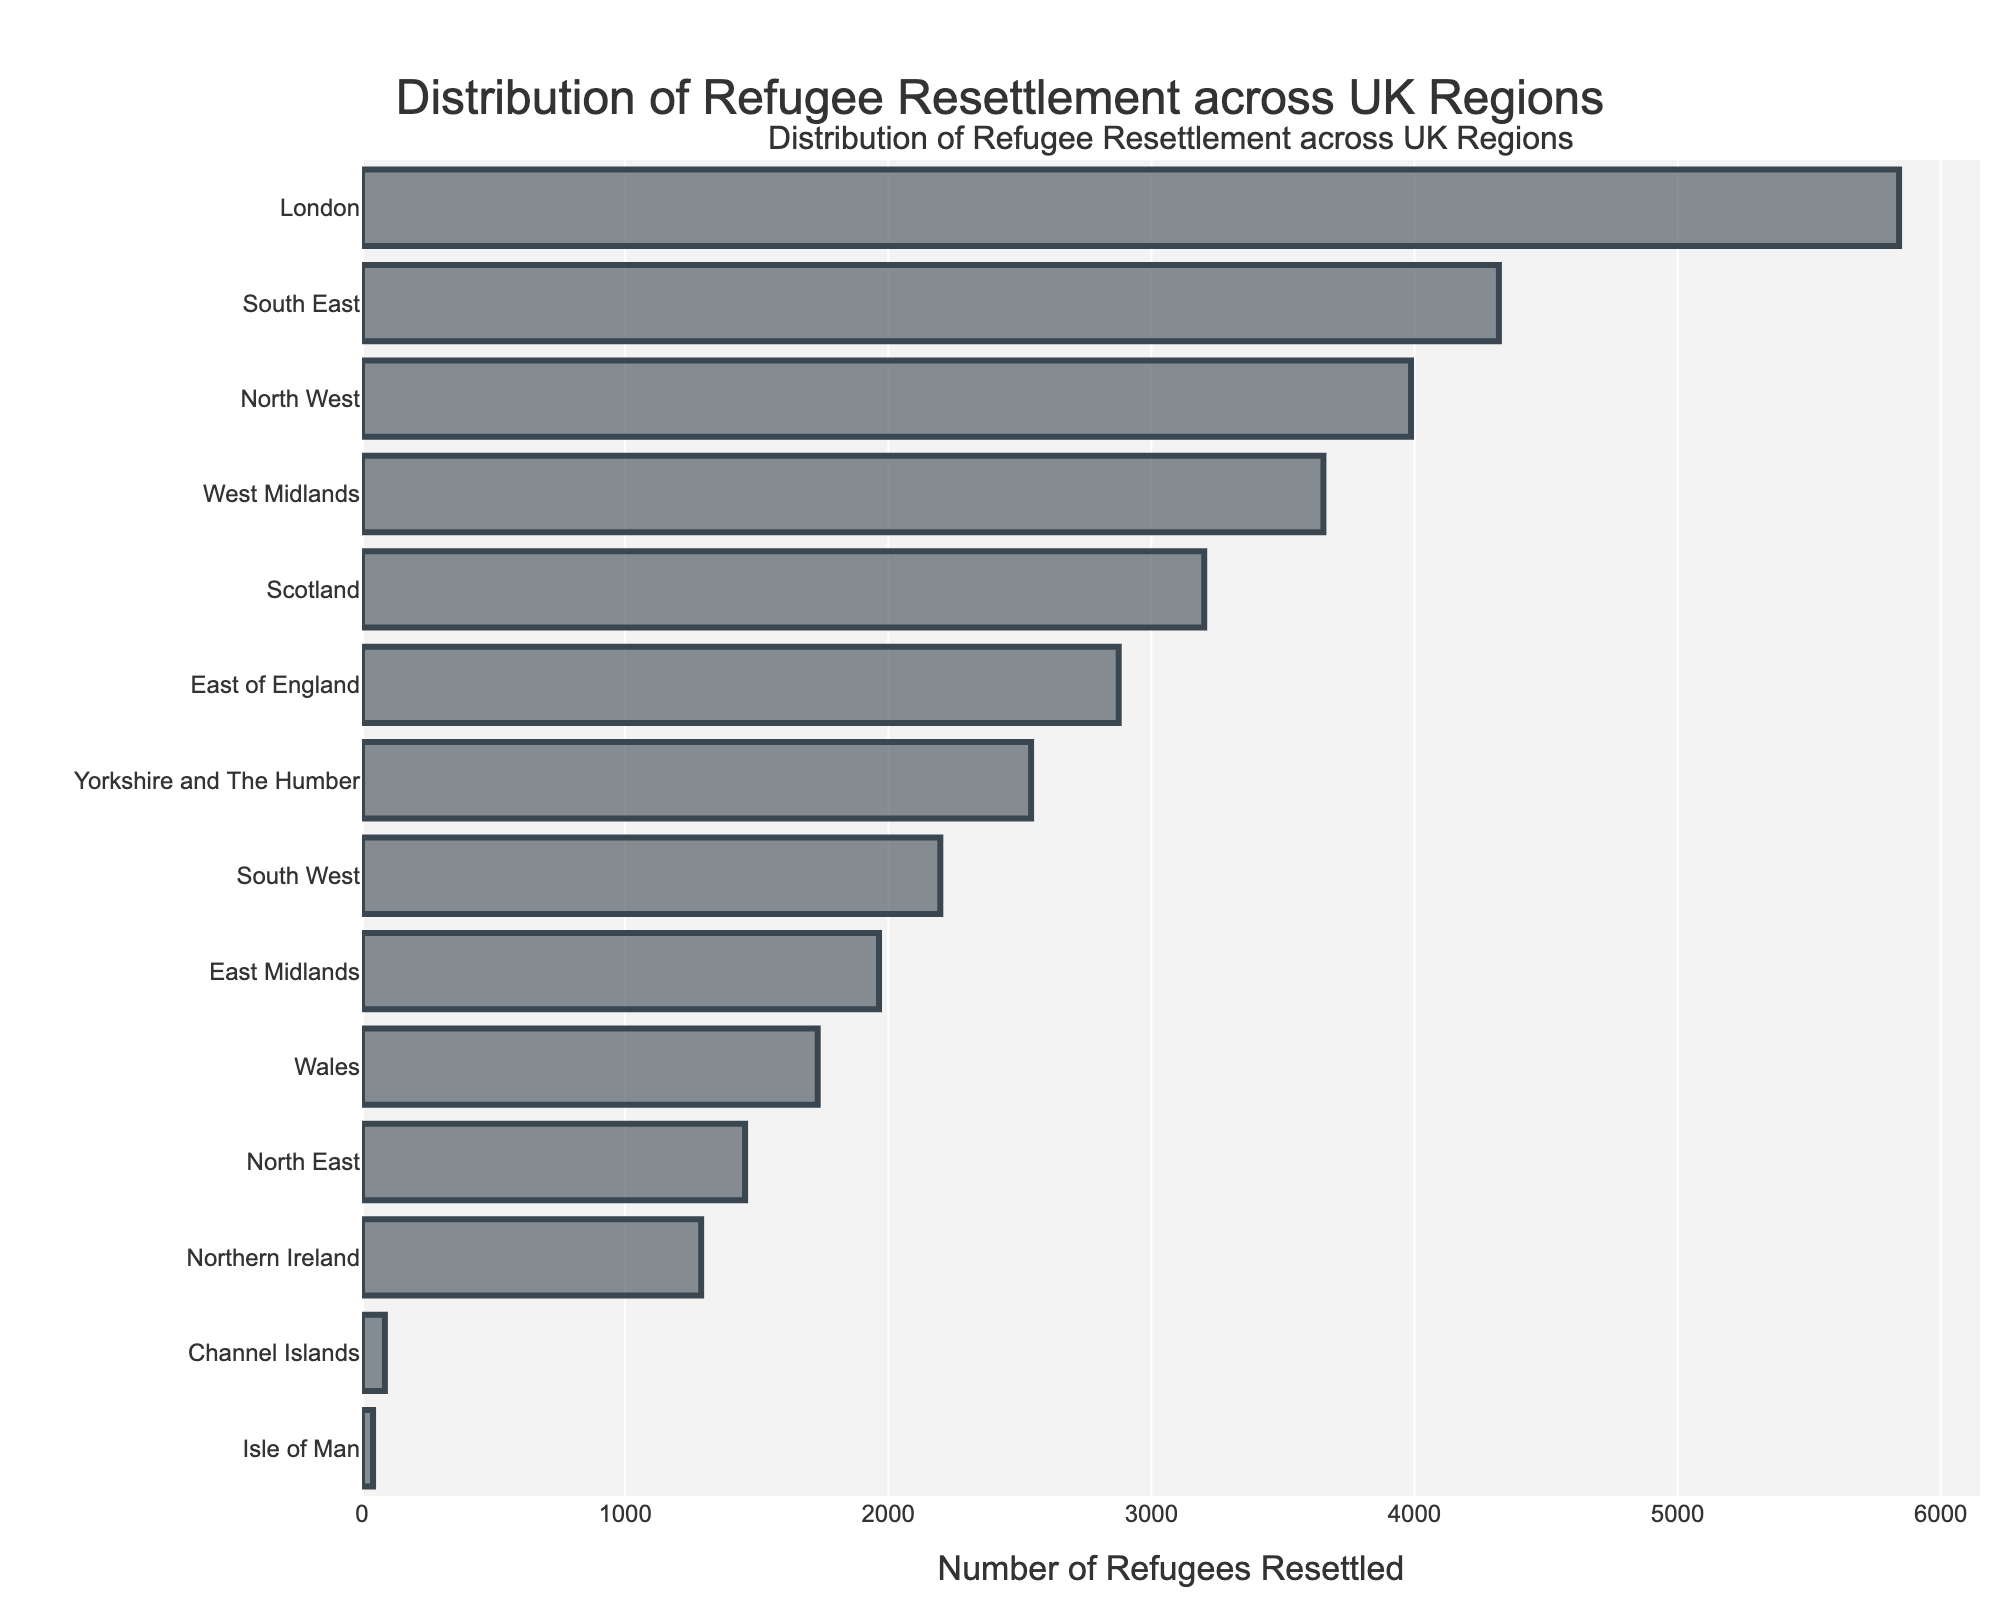Which region has resettled the highest number of refugees? By looking at the length of the bars, the bar representing London is the longest, indicating London has resettled the highest number of refugees.
Answer: London Which region has resettled fewer refugees, the North West or the West Midlands? Comparing the bars for the North West and the West Midlands, the North West bar is slightly longer, indicating the West Midlands has resettled fewer refugees.
Answer: West Midlands How many regions have resettled more than 4,000 refugees? By counting the bars that extend past the 4,000 mark on the x-axis, there are two: London and the South East.
Answer: 2 What is the total number of refugees resettled in Scotland, East of England, and Yorkshire and The Humber combined? Summing the numbers: Scotland (3,201) + East of England (2,876) + Yorkshire and The Humber (2,543) = 8,620.
Answer: 8,620 Is the number of refugees resettled in Wales greater than that in the North East? The bar for Wales is longer than the bar for the North East, indicating Wales has resettled more refugees.
Answer: Yes What is the difference between the number of refugees resettled in Northern Ireland and the East Midlands? Subtract the numbers: East Midlands (1,965) - Northern Ireland (1,289) = 676.
Answer: 676 Which region has resettled the fewest number of refugees? The shortest bar belongs to the Isle of Man, indicating it has resettled the fewest number of refugees.
Answer: Isle of Man What is the average number of refugees resettled in the top three regions? Summing the top three regions and then dividing by three: (London (5,842) + South East (4,321) + North West (3,987)) / 3 = (14,150) / 3 ≈ 4,717.
Answer: 4,717 Which region has resettled more refugees than Wales but fewer than Yorkshire and The Humber? By inspection, the East Midlands (1,965) has resettled more than Wales (1,732) but fewer than Yorkshire and The Humber (2,543).
Answer: East Midlands Among the bottom five regions, what is the total number of refugees resettled? Summing the numbers: North East (1,456) + Northern Ireland (1,289) + Channel Islands (87) + Isle of Man (42) = 2,874.
Answer: 2,874 